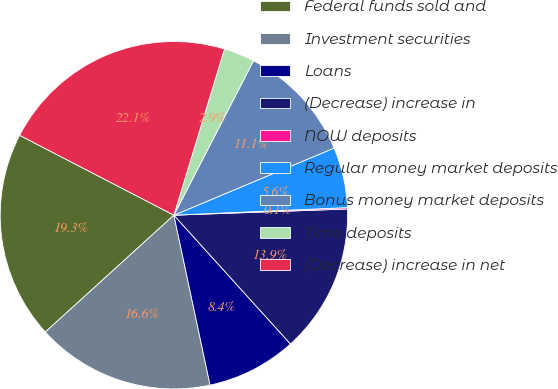Convert chart. <chart><loc_0><loc_0><loc_500><loc_500><pie_chart><fcel>Federal funds sold and<fcel>Investment securities<fcel>Loans<fcel>(Decrease) increase in<fcel>NOW deposits<fcel>Regular money market deposits<fcel>Bonus money market deposits<fcel>Time deposits<fcel>(Decrease) increase in net<nl><fcel>19.35%<fcel>16.6%<fcel>8.37%<fcel>13.86%<fcel>0.13%<fcel>5.62%<fcel>11.11%<fcel>2.87%<fcel>22.1%<nl></chart> 